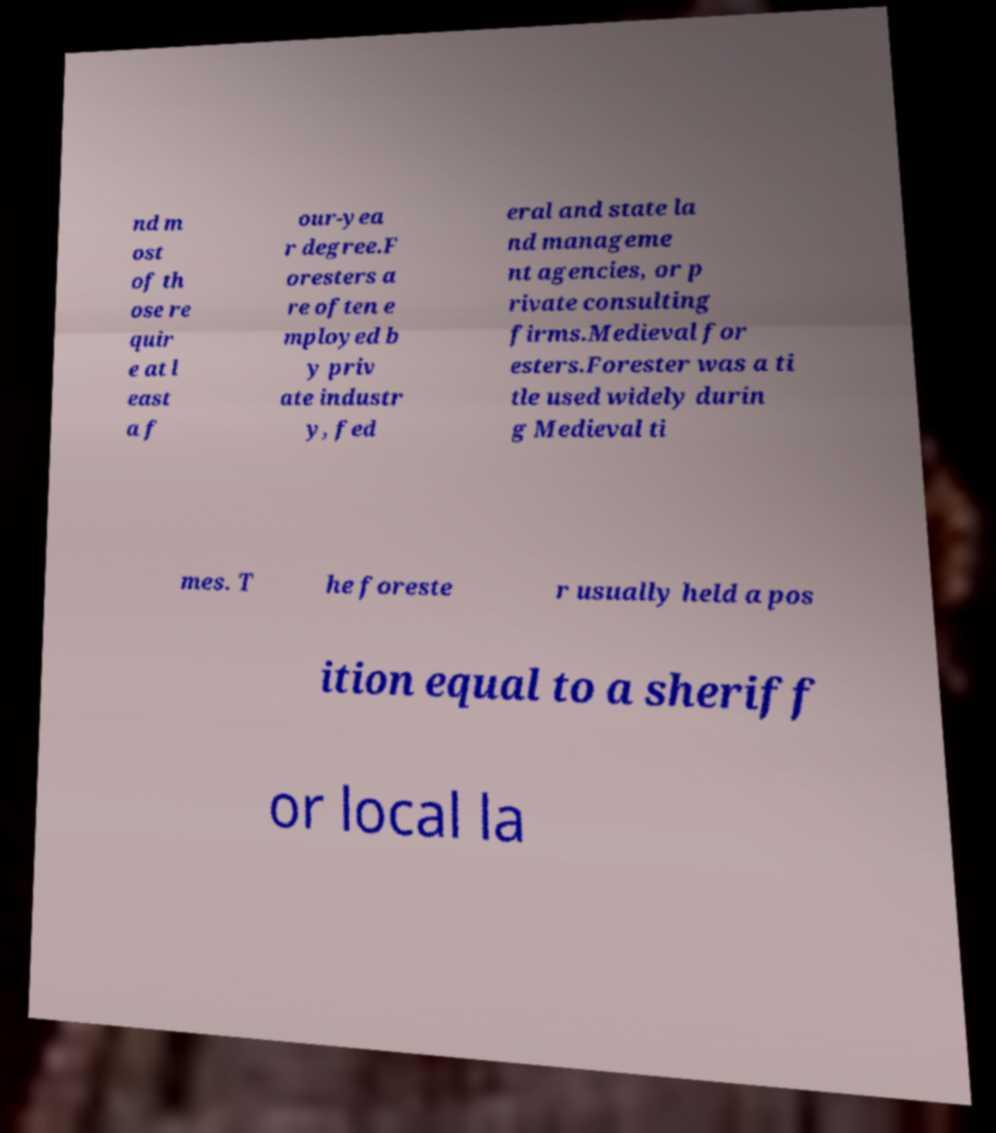Could you assist in decoding the text presented in this image and type it out clearly? nd m ost of th ose re quir e at l east a f our-yea r degree.F oresters a re often e mployed b y priv ate industr y, fed eral and state la nd manageme nt agencies, or p rivate consulting firms.Medieval for esters.Forester was a ti tle used widely durin g Medieval ti mes. T he foreste r usually held a pos ition equal to a sheriff or local la 